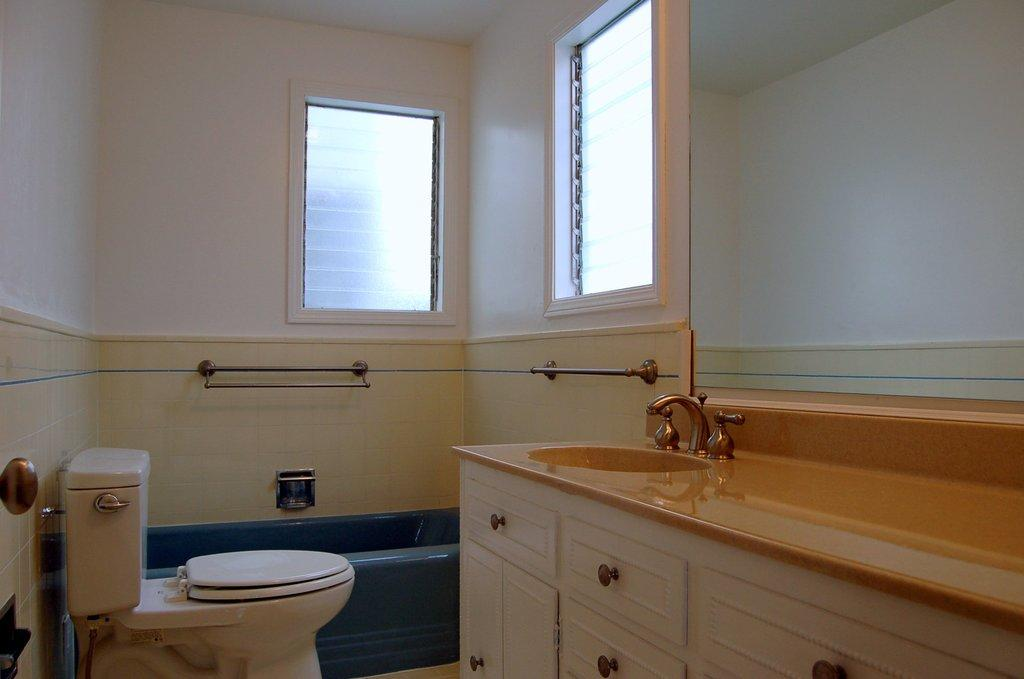Where is the image taken? The image is taken in a bathroom. What is the main fixture in the bathroom? There is a wash basin in the image. What is used to control the flow of water in the wash basin? There are taps in the image. What type of storage is available in the bathroom? There are wooden drawers in the image. What is the toilet facility in the bathroom? There is a commode in the image. How is the commode flushed? There is a flush tank in the image. What is used to hold toiletries or towels in the bathroom? There is a stand in the image. What is used for bathing in the bathroom? There is a bathtub in the image. What allows natural light and ventilation in the bathroom? There are glass ventilators in the background of the image. What type of finger can be seen holding a tent in the image? There is no finger or tent present in the image. 